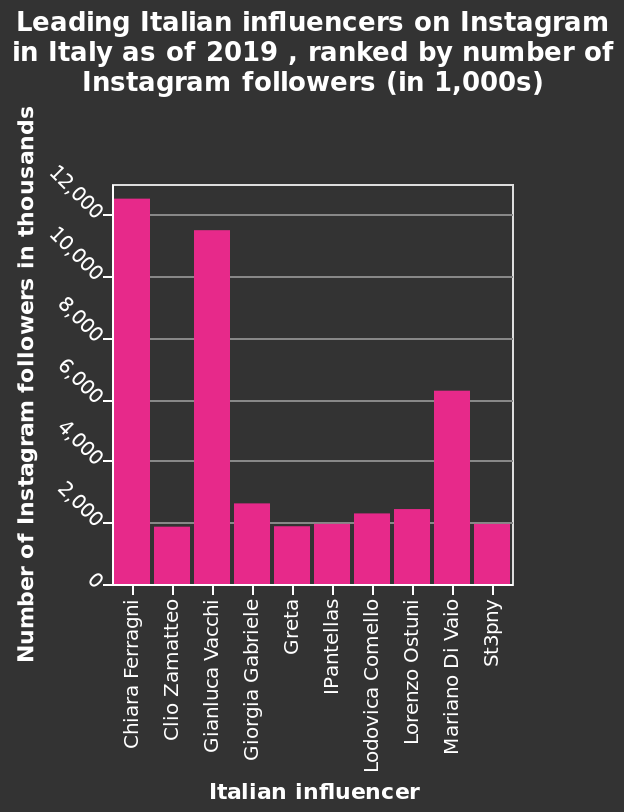<image>
What does the x-axis represent in the bar chart?  The x-axis in the bar chart represents the Italian influencers. 